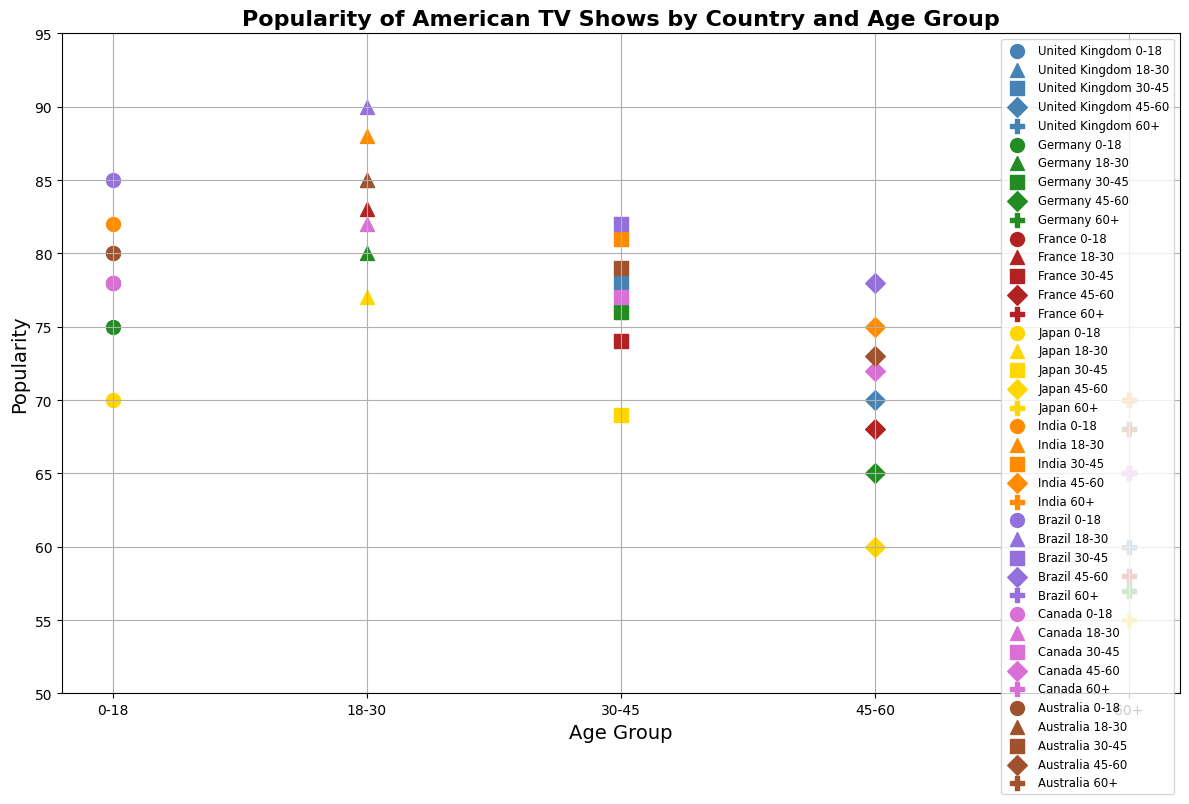What's the most popular age group for American TV shows in Brazil? In the plot, locate the data points corresponding to Brazil and compare the popularity scores across different age groups. The highest popularity score among these points will indicate the most popular age group. The data point for “18-30” in Brazil reaches the highest popularity score of 90.
Answer: 18-30 Which country shows the least interest among the 60+ age group? Identify the data points corresponding to the 60+ age group for all countries. Compare their popularity scores and find the minimum value. In this case, Japan has the lowest popularity score of 55 for the 60+ age group.
Answer: Japan Between the age groups 18-30 and 30-45 in France, which group shows a higher popularity for American TV shows? Examine the data points for France, focusing on the age groups 18-30 and 30-45. Compare their popularity scores. The score for 18-30 is 83, which is higher than 74 for the 30-45 age group.
Answer: 18-30 What’s the range of popularity scores for the UK across all age groups? Identify all the popularity scores for the UK across different age groups: 80, 85, 78, 70, and 60. The range is calculated by subtracting the smallest value from the largest value, which is 85 - 60 = 25.
Answer: 25 